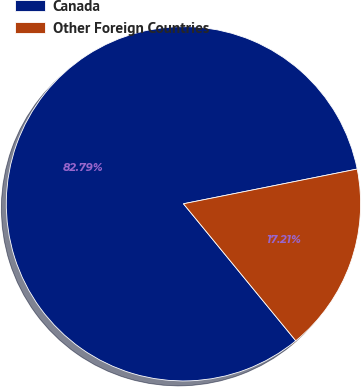Convert chart. <chart><loc_0><loc_0><loc_500><loc_500><pie_chart><fcel>Canada<fcel>Other Foreign Countries<nl><fcel>82.79%<fcel>17.21%<nl></chart> 